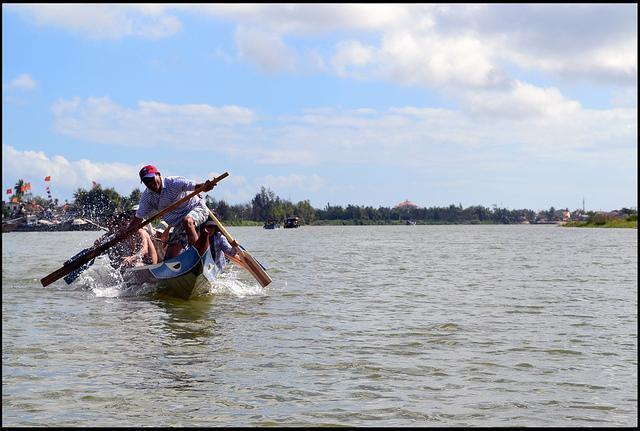How many bottles of wine are sitting on the barrel?
Give a very brief answer. 0. 